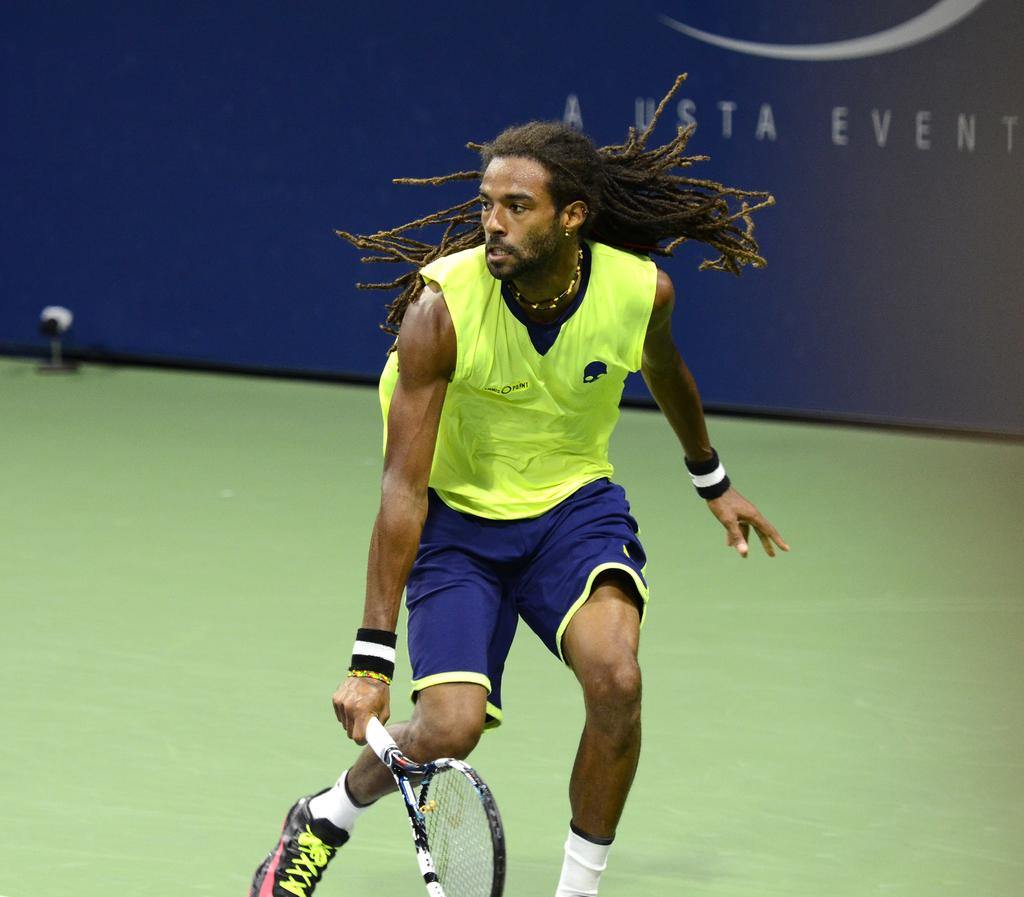What type of advertisement is shown in the image? The image is a hoarding. Can you describe the person in the image? There is a man with long hair in the image, and he is wearing wrist bands. What is the man holding in his hand? The man is holding a tennis racket in his hand. What surface is depicted in the image? The image depicts a floor. What is the cause of the man's temper in the image? There is no indication of the man's temper in the image, and therefore no cause can be determined. --- Facts: 1. There is a person sitting on a chair in the image. 2. The person is holding a book. 3. The book has a blue cover. 4. The chair is made of wood. 5. There is a window behind the person. Absurd Topics: parrot, ocean, dance Conversation: What is the person in the image doing? The person is sitting on a chair in the image. What object is the person holding? The person is holding a book. Can you describe the book's appearance? The book has a blue cover. What material is the chair made of? The chair is made of wood. What can be seen behind the person? There is a window behind the person. Reasoning: Let's think step by step in order to produce the conversation. We start by identifying the main subject in the image, which is the person sitting on a chair. Then, we expand the conversation to include the object the person is holding, which is a book with a blue cover. Next, we mention the material of the chair, which is wood. Finally, we describe the background element, which is a window. Absurd Question/Answer: Can you tell me how many parrots are sitting on the person's shoulder in the image? There are no parrots present in the image. What type of dance is the person performing in the image? There is no dance being performed in the image; the person is simply sitting on a chair and holding a book. 